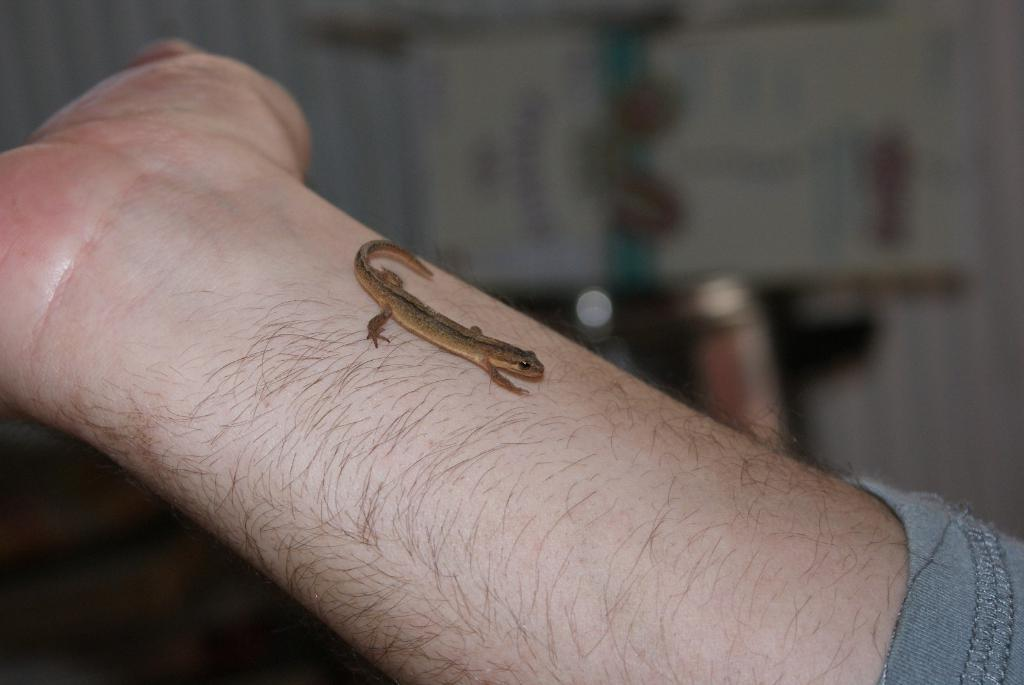What type of animal is in the image? There is a lizard in the image. Where is the lizard located in the image? The lizard is on a person's hand. What type of berry is hanging from the bells in the image? There are no berries or bells present in the image; it features a lizard on a person's hand. 